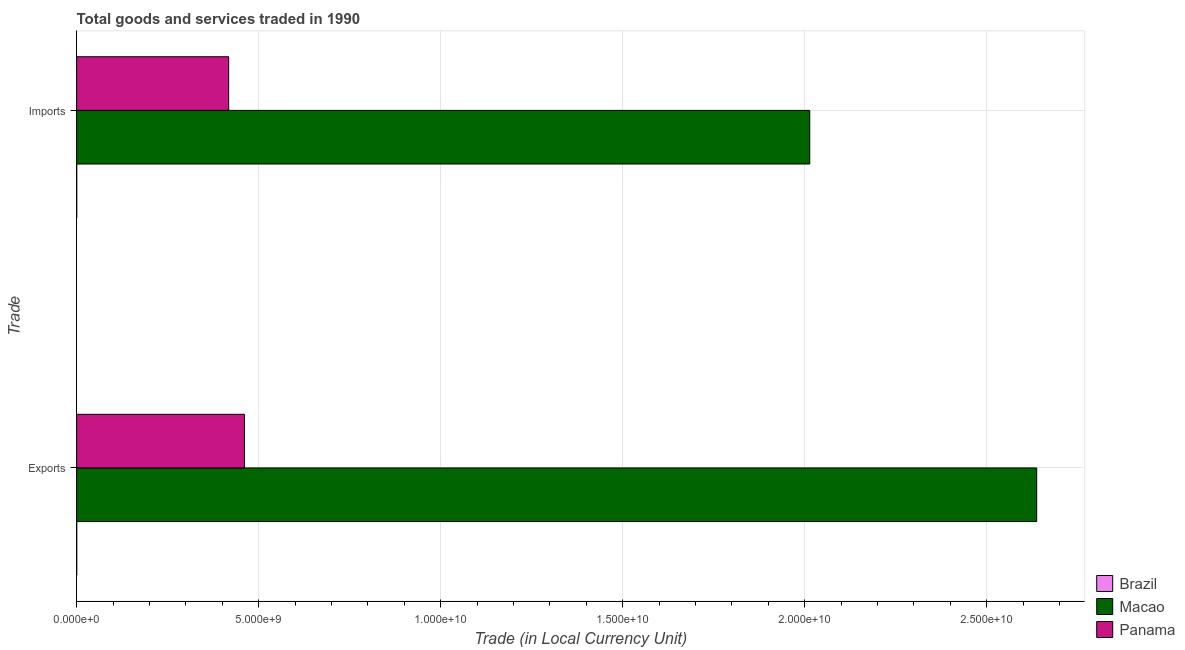Are the number of bars on each tick of the Y-axis equal?
Your answer should be very brief. Yes. How many bars are there on the 2nd tick from the bottom?
Offer a terse response. 3. What is the label of the 1st group of bars from the top?
Ensure brevity in your answer.  Imports. What is the imports of goods and services in Macao?
Offer a terse response. 2.01e+1. Across all countries, what is the maximum export of goods and services?
Provide a succinct answer. 2.64e+1. Across all countries, what is the minimum imports of goods and services?
Provide a succinct answer. 8.04e+05. In which country was the imports of goods and services maximum?
Provide a short and direct response. Macao. In which country was the imports of goods and services minimum?
Keep it short and to the point. Brazil. What is the total imports of goods and services in the graph?
Your response must be concise. 2.43e+1. What is the difference between the export of goods and services in Brazil and that in Panama?
Your answer should be very brief. -4.61e+09. What is the difference between the export of goods and services in Macao and the imports of goods and services in Brazil?
Your response must be concise. 2.64e+1. What is the average imports of goods and services per country?
Give a very brief answer. 8.11e+09. What is the difference between the imports of goods and services and export of goods and services in Panama?
Your response must be concise. -4.35e+08. What is the ratio of the imports of goods and services in Brazil to that in Panama?
Your answer should be compact. 0. Is the export of goods and services in Macao less than that in Brazil?
Your answer should be very brief. No. What does the 2nd bar from the top in Imports represents?
Your answer should be compact. Macao. What does the 2nd bar from the bottom in Imports represents?
Keep it short and to the point. Macao. Are all the bars in the graph horizontal?
Give a very brief answer. Yes. Are the values on the major ticks of X-axis written in scientific E-notation?
Provide a short and direct response. Yes. Where does the legend appear in the graph?
Ensure brevity in your answer.  Bottom right. How are the legend labels stacked?
Offer a very short reply. Vertical. What is the title of the graph?
Keep it short and to the point. Total goods and services traded in 1990. Does "Burkina Faso" appear as one of the legend labels in the graph?
Ensure brevity in your answer.  No. What is the label or title of the X-axis?
Your response must be concise. Trade (in Local Currency Unit). What is the label or title of the Y-axis?
Make the answer very short. Trade. What is the Trade (in Local Currency Unit) in Brazil in Exports?
Your answer should be compact. 9.47e+05. What is the Trade (in Local Currency Unit) in Macao in Exports?
Provide a short and direct response. 2.64e+1. What is the Trade (in Local Currency Unit) in Panama in Exports?
Offer a terse response. 4.61e+09. What is the Trade (in Local Currency Unit) of Brazil in Imports?
Give a very brief answer. 8.04e+05. What is the Trade (in Local Currency Unit) of Macao in Imports?
Offer a terse response. 2.01e+1. What is the Trade (in Local Currency Unit) in Panama in Imports?
Keep it short and to the point. 4.18e+09. Across all Trade, what is the maximum Trade (in Local Currency Unit) of Brazil?
Your answer should be compact. 9.47e+05. Across all Trade, what is the maximum Trade (in Local Currency Unit) in Macao?
Make the answer very short. 2.64e+1. Across all Trade, what is the maximum Trade (in Local Currency Unit) in Panama?
Ensure brevity in your answer.  4.61e+09. Across all Trade, what is the minimum Trade (in Local Currency Unit) of Brazil?
Your response must be concise. 8.04e+05. Across all Trade, what is the minimum Trade (in Local Currency Unit) of Macao?
Your answer should be very brief. 2.01e+1. Across all Trade, what is the minimum Trade (in Local Currency Unit) of Panama?
Offer a terse response. 4.18e+09. What is the total Trade (in Local Currency Unit) in Brazil in the graph?
Provide a short and direct response. 1.75e+06. What is the total Trade (in Local Currency Unit) of Macao in the graph?
Your response must be concise. 4.65e+1. What is the total Trade (in Local Currency Unit) in Panama in the graph?
Your answer should be compact. 8.79e+09. What is the difference between the Trade (in Local Currency Unit) in Brazil in Exports and that in Imports?
Provide a short and direct response. 1.43e+05. What is the difference between the Trade (in Local Currency Unit) in Macao in Exports and that in Imports?
Keep it short and to the point. 6.24e+09. What is the difference between the Trade (in Local Currency Unit) in Panama in Exports and that in Imports?
Make the answer very short. 4.35e+08. What is the difference between the Trade (in Local Currency Unit) in Brazil in Exports and the Trade (in Local Currency Unit) in Macao in Imports?
Your response must be concise. -2.01e+1. What is the difference between the Trade (in Local Currency Unit) of Brazil in Exports and the Trade (in Local Currency Unit) of Panama in Imports?
Offer a very short reply. -4.18e+09. What is the difference between the Trade (in Local Currency Unit) of Macao in Exports and the Trade (in Local Currency Unit) of Panama in Imports?
Keep it short and to the point. 2.22e+1. What is the average Trade (in Local Currency Unit) in Brazil per Trade?
Offer a terse response. 8.76e+05. What is the average Trade (in Local Currency Unit) of Macao per Trade?
Your response must be concise. 2.33e+1. What is the average Trade (in Local Currency Unit) in Panama per Trade?
Offer a terse response. 4.39e+09. What is the difference between the Trade (in Local Currency Unit) in Brazil and Trade (in Local Currency Unit) in Macao in Exports?
Ensure brevity in your answer.  -2.64e+1. What is the difference between the Trade (in Local Currency Unit) of Brazil and Trade (in Local Currency Unit) of Panama in Exports?
Offer a terse response. -4.61e+09. What is the difference between the Trade (in Local Currency Unit) of Macao and Trade (in Local Currency Unit) of Panama in Exports?
Your answer should be compact. 2.18e+1. What is the difference between the Trade (in Local Currency Unit) in Brazil and Trade (in Local Currency Unit) in Macao in Imports?
Offer a very short reply. -2.01e+1. What is the difference between the Trade (in Local Currency Unit) in Brazil and Trade (in Local Currency Unit) in Panama in Imports?
Offer a very short reply. -4.18e+09. What is the difference between the Trade (in Local Currency Unit) of Macao and Trade (in Local Currency Unit) of Panama in Imports?
Make the answer very short. 1.60e+1. What is the ratio of the Trade (in Local Currency Unit) in Brazil in Exports to that in Imports?
Make the answer very short. 1.18. What is the ratio of the Trade (in Local Currency Unit) of Macao in Exports to that in Imports?
Give a very brief answer. 1.31. What is the ratio of the Trade (in Local Currency Unit) of Panama in Exports to that in Imports?
Provide a short and direct response. 1.1. What is the difference between the highest and the second highest Trade (in Local Currency Unit) in Brazil?
Offer a very short reply. 1.43e+05. What is the difference between the highest and the second highest Trade (in Local Currency Unit) in Macao?
Your answer should be compact. 6.24e+09. What is the difference between the highest and the second highest Trade (in Local Currency Unit) in Panama?
Offer a terse response. 4.35e+08. What is the difference between the highest and the lowest Trade (in Local Currency Unit) in Brazil?
Your answer should be very brief. 1.43e+05. What is the difference between the highest and the lowest Trade (in Local Currency Unit) in Macao?
Your answer should be very brief. 6.24e+09. What is the difference between the highest and the lowest Trade (in Local Currency Unit) in Panama?
Offer a terse response. 4.35e+08. 